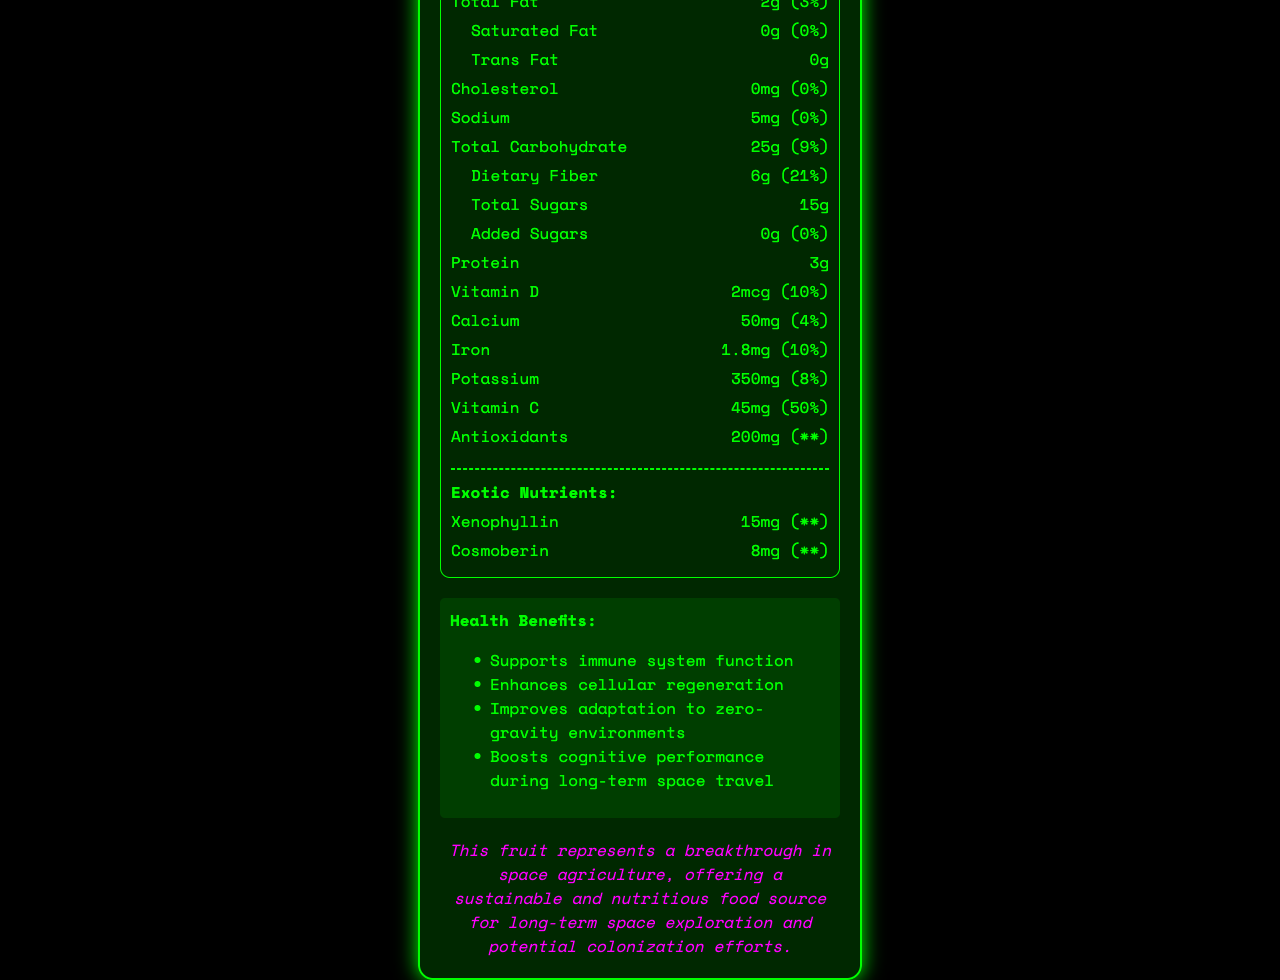what is the serving size for Stellaris Fruit? The serving size is explicitly mentioned as "1 medium fruit (150g)" in the document under the nutrition facts heading.
Answer: 1 medium fruit (150g) how many calories are in one serving of Stellaris Fruit? The document lists "Calories" as 120 in the prominent nutrient section under the nutrition facts.
Answer: 120 which nutrient has the highest daily value percentage in Stellaris Fruit? A. Vitamin C B. Dietary Fiber C. Potassium D. Calcium As per the document, Vitamin C has a daily value of 50%, which is the highest among the listed nutrients.
Answer: A. Vitamin C what are the two exotic nutrients found in Stellaris Fruit? The document mentions "Exotic Nutrients" explicitly, listing Xenophyllin and Cosmoberin.
Answer: Xenophyllin, Cosmoberin is Stellaris Fruit approved for human consumption? The document states it has been "Approved for human consumption after rigorous testing by the Interstellar Food and Drug Administration (IFDA)".
Answer: Yes summarize the main idea of the document. The document provides detailed nutrition facts, health benefits, and the significance of Stellaris Fruit for long-term space exploration, emphasizing its nutritional value and cultivation success in controlled environments.
Answer: The Stellaris Fruit is an exotic alien fruit discovered on Kepler-186f with a wide array of nutritional benefits suitable for space explorers. It has a unique nutrient profile, supports various health benefits, and represents hope for sustainable food sources in space agriculture. does the Stellaris Fruit contain any trans fat? The document specifies "Trans Fat: 0g," indicating no trans fat in the fruit.
Answer: No how should Stellaris Fruit be stored for best quality? The optimal storage temperature is mentioned in the document under the storage section.
Answer: At temperatures between 10-15°C (50-59°F) what percentage of daily value for fiber does Stellaris Fruit provide? The dietary fiber section under total carbohydrate indicates a daily value of 21%.
Answer: 21% which benefit is NOT listed for Stellaris Fruit? A. Supports immune system function B. Enhances cellular regeneration C. Reduces stress D. Boosts cognitive performance during long-term space travel The health benefits section lists all options except for "Reduces stress."
Answer: C. Reduces stress where was Stellaris Fruit discovered? The document clearly mentions the origin as "Discovered on exoplanet Kepler-186f."
Answer: Exoplanet Kepler-186f what is the taste profile of Stellaris Fruit? The description under the taste profile section offers this information.
Answer: Sweet with hints of citrus and berries, slightly effervescent which nutrient in Stellaris Fruit supports adaptation to zero-gravity environments? The document lists "Improves adaptation to zero-gravity environments" as a benefit but does not specify which nutrient is responsible for this effect.
Answer: Not enough information 